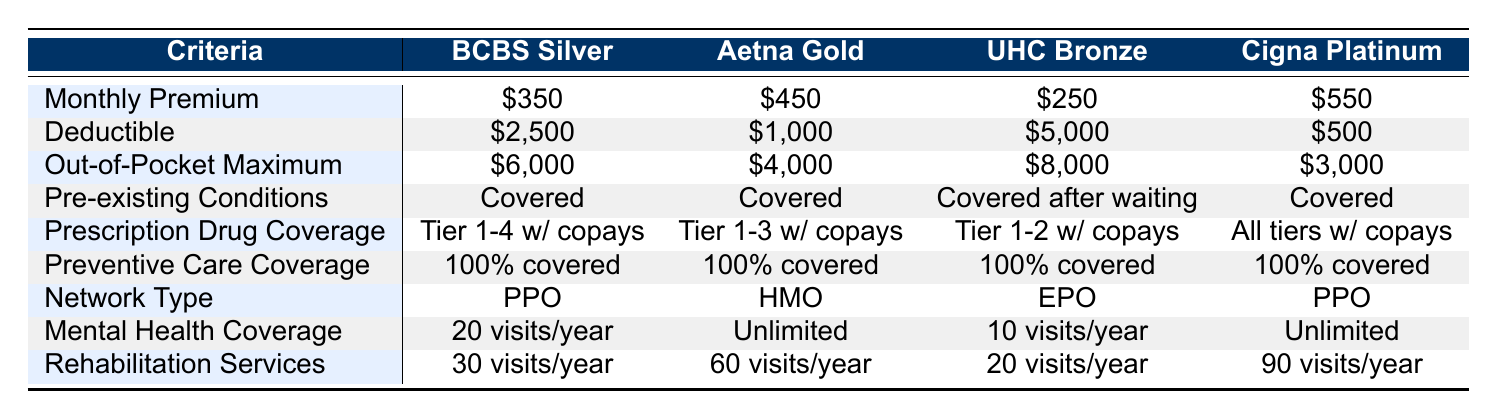What is the monthly premium for the Aetna Gold Plan? The Aetna Gold Plan monthly premium is listed in the first row under the Aetna Gold column. It shows a monthly premium of $450.
Answer: $450 Which plan has the lowest out-of-pocket maximum? The out-of-pocket maximum for each plan is compared in the respective rows. The lowest value is $3,000 for the Cigna Platinum Plan.
Answer: $3,000 Does the UnitedHealthcare Bronze Plan cover pre-existing conditions without a waiting period? The UnitedHealthcare Bronze Plan specifies "Covered after waiting period" for pre-existing conditions. Therefore, it does not cover them without a waiting period.
Answer: No How many visits per year are covered for mental health under the Blue Cross Blue Shield Silver Plan? Referring to the Blue Cross Blue Shield Silver Plan row, it states "20 visits per year" for mental health coverage.
Answer: 20 visits What is the difference in the monthly premium between the Cigna Platinum Plan and the UnitedHealthcare Bronze Plan? The monthly premium for the Cigna Platinum Plan is $550, and for the UnitedHealthcare Bronze Plan, it is $250. The difference is $550 - $250 = $300.
Answer: $300 Which plan provides the most rehabilitation services per year? The rehabilitation services row shows that the Cigna Platinum Plan offers 90 visits per year, more than any other plan.
Answer: Cigna Platinum Plan What type of provider network does the Aetna Gold Plan use? The Aetna Gold Plan is categorized under the "Network Type" row, which indicates that it uses an HMO provider network.
Answer: HMO Is preventive care coverage 100% for all the plans? The preventive care coverage row indicates that all plans show "100% covered," confirming that every plan includes this coverage.
Answer: Yes Which insurance plan has the highest deductible? By examining the deductible row, the UnitedHealthcare Bronze Plan has the highest deductible at $5,000.
Answer: UnitedHealthcare Bronze Plan 